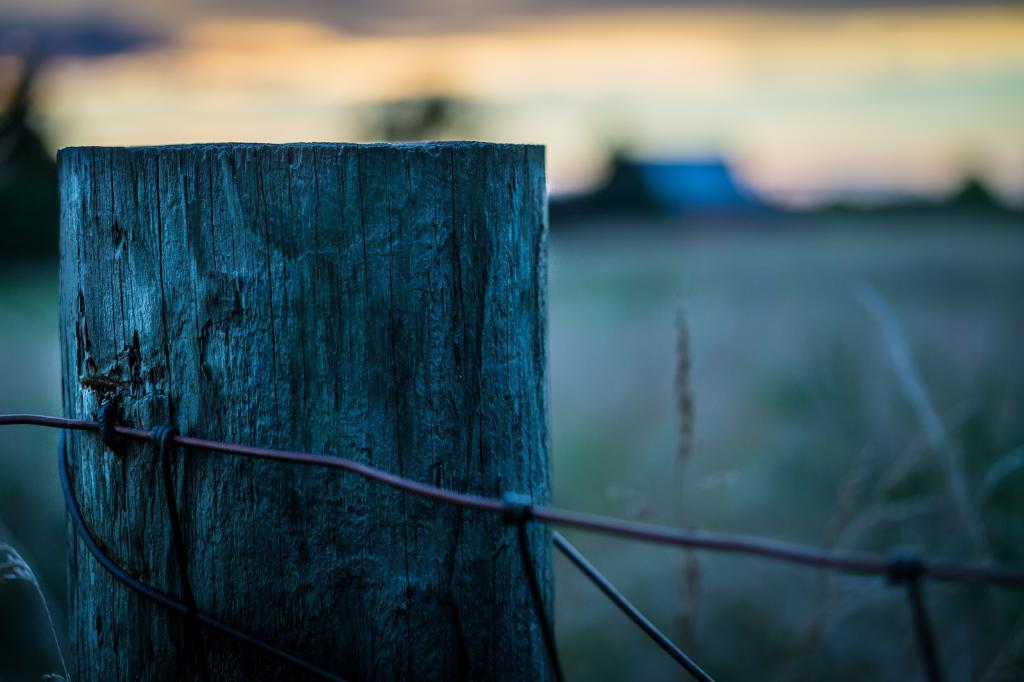What object is present in the image that is made of wood? There is a wooden pole in the image. Who or what can be seen in the image besides the wooden pole? There is a girl in the image. Can you describe the background of the image? The background of the image is blurred. What type of soup is the girl eating in the image? There is no soup present in the image; it features a wooden pole and a girl. Can you tell me which direction the porter is facing in the image? There is no porter present in the image. 